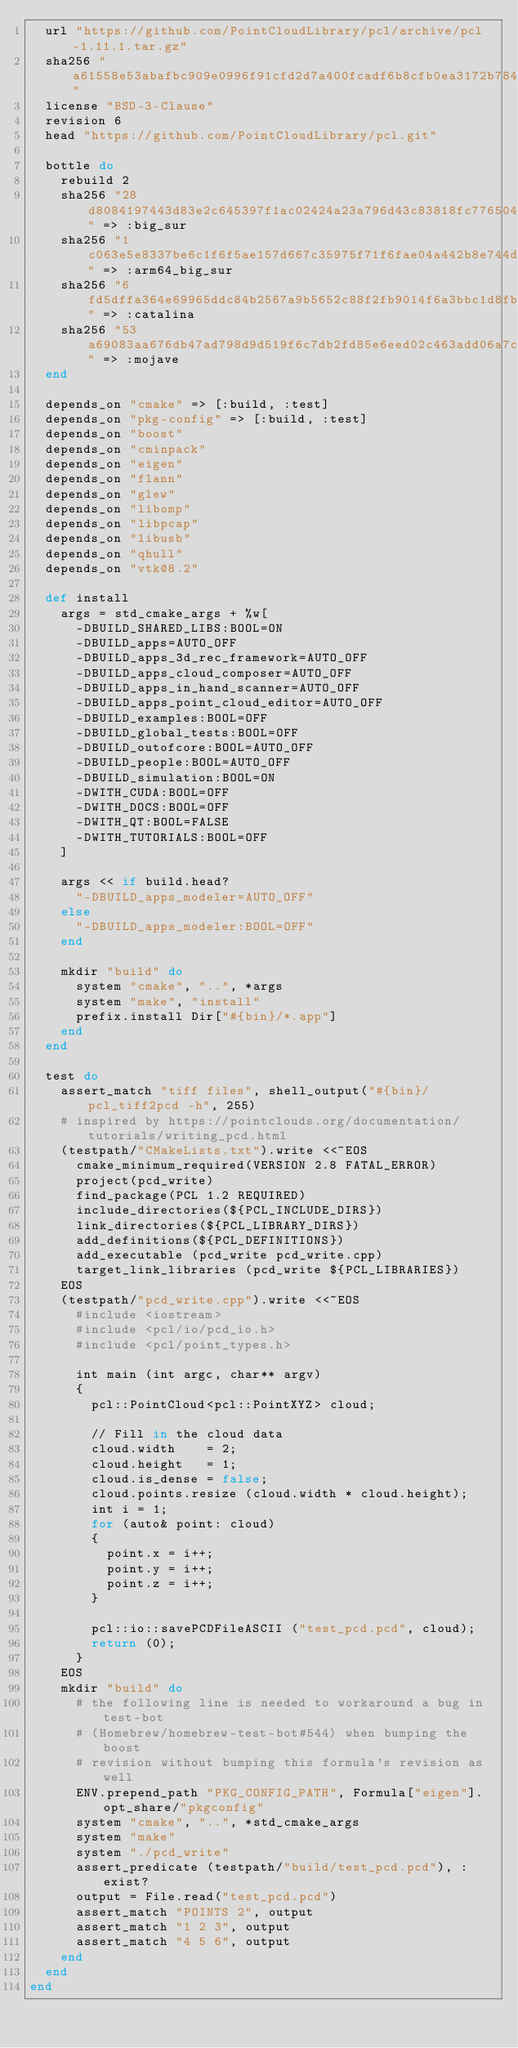<code> <loc_0><loc_0><loc_500><loc_500><_Ruby_>  url "https://github.com/PointCloudLibrary/pcl/archive/pcl-1.11.1.tar.gz"
  sha256 "a61558e53abafbc909e0996f91cfd2d7a400fcadf6b8cfb0ea3172b78422c74e"
  license "BSD-3-Clause"
  revision 6
  head "https://github.com/PointCloudLibrary/pcl.git"

  bottle do
    rebuild 2
    sha256 "28d8084197443d83e2c645397f1ac02424a23a796d43c83818fc776504c5ff7e" => :big_sur
    sha256 "1c063e5e8337be6c1f6f5ae157d667c35975f71f6fae04a442b8e744d3107d32" => :arm64_big_sur
    sha256 "6fd5dffa364e69965ddc84b2567a9b5652c88f2fb9014f6a3bbc1d8fb612f089" => :catalina
    sha256 "53a69083aa676db47ad798d9d519f6c7db2fd85e6eed02c463add06a7c0485ea" => :mojave
  end

  depends_on "cmake" => [:build, :test]
  depends_on "pkg-config" => [:build, :test]
  depends_on "boost"
  depends_on "cminpack"
  depends_on "eigen"
  depends_on "flann"
  depends_on "glew"
  depends_on "libomp"
  depends_on "libpcap"
  depends_on "libusb"
  depends_on "qhull"
  depends_on "vtk@8.2"

  def install
    args = std_cmake_args + %w[
      -DBUILD_SHARED_LIBS:BOOL=ON
      -DBUILD_apps=AUTO_OFF
      -DBUILD_apps_3d_rec_framework=AUTO_OFF
      -DBUILD_apps_cloud_composer=AUTO_OFF
      -DBUILD_apps_in_hand_scanner=AUTO_OFF
      -DBUILD_apps_point_cloud_editor=AUTO_OFF
      -DBUILD_examples:BOOL=OFF
      -DBUILD_global_tests:BOOL=OFF
      -DBUILD_outofcore:BOOL=AUTO_OFF
      -DBUILD_people:BOOL=AUTO_OFF
      -DBUILD_simulation:BOOL=ON
      -DWITH_CUDA:BOOL=OFF
      -DWITH_DOCS:BOOL=OFF
      -DWITH_QT:BOOL=FALSE
      -DWITH_TUTORIALS:BOOL=OFF
    ]

    args << if build.head?
      "-DBUILD_apps_modeler=AUTO_OFF"
    else
      "-DBUILD_apps_modeler:BOOL=OFF"
    end

    mkdir "build" do
      system "cmake", "..", *args
      system "make", "install"
      prefix.install Dir["#{bin}/*.app"]
    end
  end

  test do
    assert_match "tiff files", shell_output("#{bin}/pcl_tiff2pcd -h", 255)
    # inspired by https://pointclouds.org/documentation/tutorials/writing_pcd.html
    (testpath/"CMakeLists.txt").write <<~EOS
      cmake_minimum_required(VERSION 2.8 FATAL_ERROR)
      project(pcd_write)
      find_package(PCL 1.2 REQUIRED)
      include_directories(${PCL_INCLUDE_DIRS})
      link_directories(${PCL_LIBRARY_DIRS})
      add_definitions(${PCL_DEFINITIONS})
      add_executable (pcd_write pcd_write.cpp)
      target_link_libraries (pcd_write ${PCL_LIBRARIES})
    EOS
    (testpath/"pcd_write.cpp").write <<~EOS
      #include <iostream>
      #include <pcl/io/pcd_io.h>
      #include <pcl/point_types.h>

      int main (int argc, char** argv)
      {
        pcl::PointCloud<pcl::PointXYZ> cloud;

        // Fill in the cloud data
        cloud.width    = 2;
        cloud.height   = 1;
        cloud.is_dense = false;
        cloud.points.resize (cloud.width * cloud.height);
        int i = 1;
        for (auto& point: cloud)
        {
          point.x = i++;
          point.y = i++;
          point.z = i++;
        }

        pcl::io::savePCDFileASCII ("test_pcd.pcd", cloud);
        return (0);
      }
    EOS
    mkdir "build" do
      # the following line is needed to workaround a bug in test-bot
      # (Homebrew/homebrew-test-bot#544) when bumping the boost
      # revision without bumping this formula's revision as well
      ENV.prepend_path "PKG_CONFIG_PATH", Formula["eigen"].opt_share/"pkgconfig"
      system "cmake", "..", *std_cmake_args
      system "make"
      system "./pcd_write"
      assert_predicate (testpath/"build/test_pcd.pcd"), :exist?
      output = File.read("test_pcd.pcd")
      assert_match "POINTS 2", output
      assert_match "1 2 3", output
      assert_match "4 5 6", output
    end
  end
end
</code> 